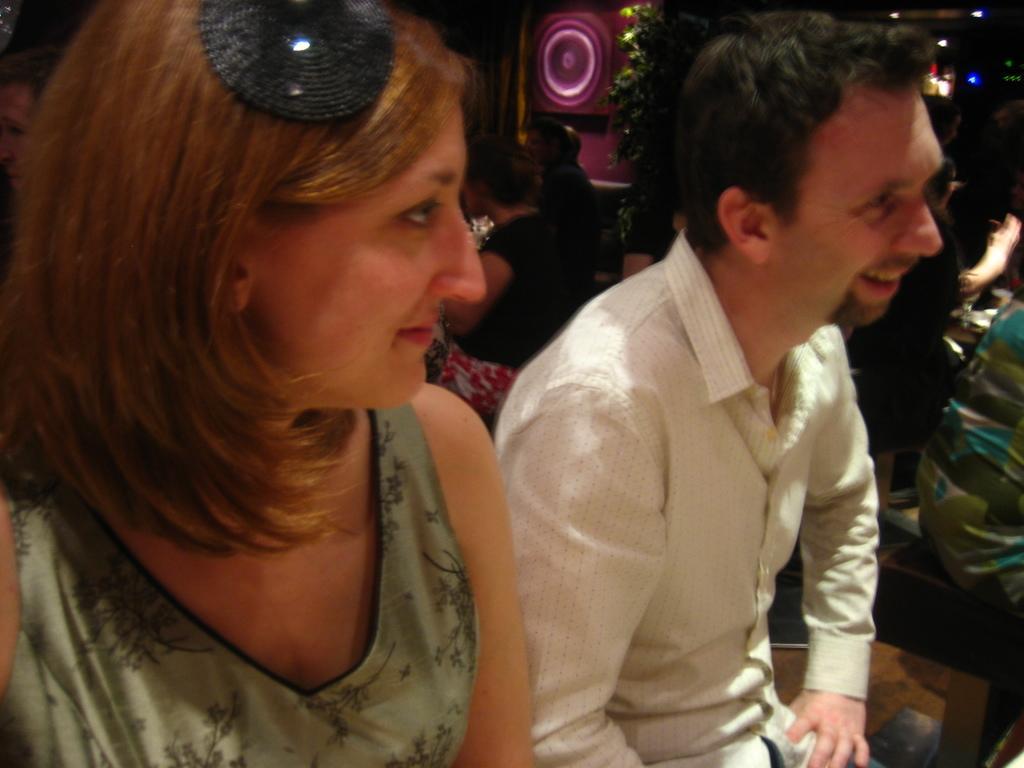Can you describe this image briefly? In this image I can see a woman and a man are sitting and smiling by looking at the right side. In the background, I can see some more people in the dark and also there are few lights. 